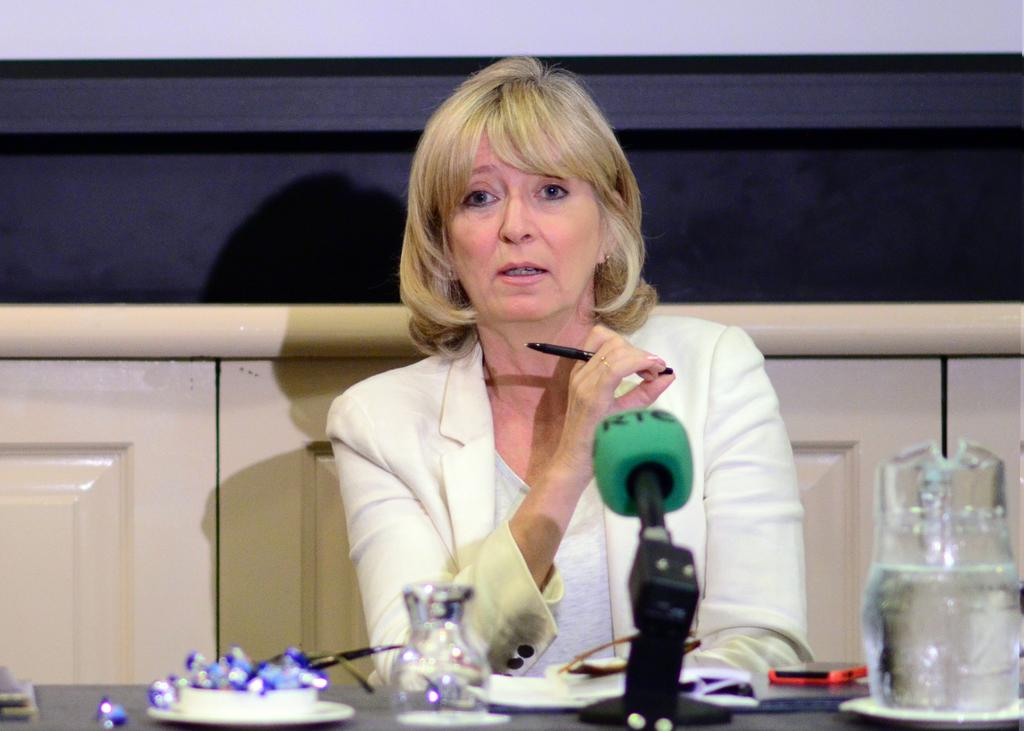<image>
Describe the image concisely. A blonde woman is sitting at a table by a green microphone that says RTC. 